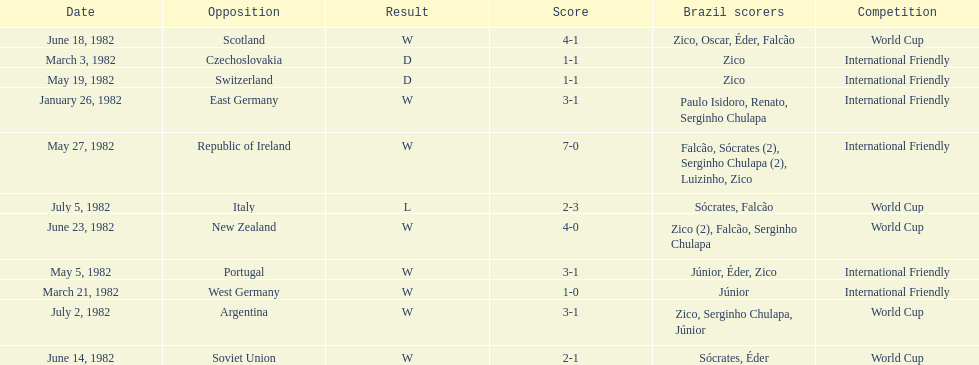How many games did zico end up scoring in during this season? 7. 